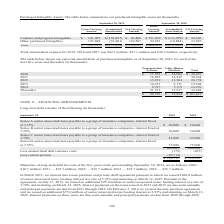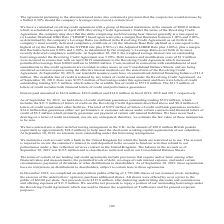According to Cubic's financial document, What is the maturity of long-term debt for 2021? According to the financial document, $35.7 million. The relevant text states: "2024, are as follows: 2020 — $10.7 million; 2021 — $35.7 million; 2022 — $35.7 million; 2023 — $35.7 million; 2024 — $35.7 million. In March 2013, we entered into a 2024, are as follows: 2020 — $10.7 ..." Also, What are the different series of senior unsecured notes payable to a group of insurance companies? The document contains multiple relevant values: Series A, Series B, Series C, Series D. From the document: "Series A senior unsecured notes payable to a group of insurance companies, interest fixed at 3.35% $ 50,000 Series A senior unsecured notes payable to..." Also, What are the different interest rates for the different senior unsecured notes payable to a group of insurance companies? The document contains multiple relevant values: 3.35%, 3.70%, 3.93%. From the document: "a group of insurance companies, interest fixed at 3.93% 75,000 75,000 a group of insurance companies, interest fixed at 3.35% $ 50,000 $ 50,000 Series..." Additionally, Which series of senior unsecured notes payable to a group of insurance companies is fixed at the largest interest rate? According to the financial document, Series D. The relevant text states: "companies, interest fixed at 3.70% 25,000 25,000 Series D senior unsecured notes payable to a group of insurance companies, interest fixed at 3.93% 75,000 75..." Also, can you calculate: What is the change in the total amount of long-term debt in 2019 from 2018? Based on the calculation: 189,111-199,793, the result is -10682 (in thousands). This is based on the information: "Less current portion (10,714) — $ 189,111 $ 199,793 Less current portion (10,714) — $ 189,111 $ 199,793..." The key data points involved are: 189,111, 199,793. Also, can you calculate: What is the percentage change in the total amount of long-term debt in 2019 from 2018? To answer this question, I need to perform calculations using the financial data. The calculation is: (189,111-199,793)/199,793, which equals -5.35 (percentage). This is based on the information: "Less current portion (10,714) — $ 189,111 $ 199,793 Less current portion (10,714) — $ 189,111 $ 199,793..." The key data points involved are: 189,111, 199,793. 